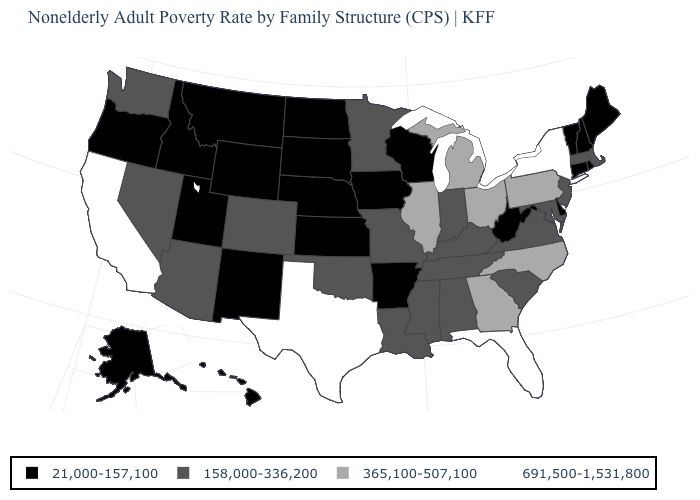Which states hav the highest value in the West?
Quick response, please. California. What is the value of Missouri?
Concise answer only. 158,000-336,200. Which states hav the highest value in the West?
Be succinct. California. What is the value of North Carolina?
Quick response, please. 365,100-507,100. Does North Dakota have the lowest value in the MidWest?
Write a very short answer. Yes. What is the highest value in states that border Vermont?
Quick response, please. 691,500-1,531,800. Name the states that have a value in the range 365,100-507,100?
Give a very brief answer. Georgia, Illinois, Michigan, North Carolina, Ohio, Pennsylvania. Name the states that have a value in the range 365,100-507,100?
Quick response, please. Georgia, Illinois, Michigan, North Carolina, Ohio, Pennsylvania. What is the value of Alabama?
Quick response, please. 158,000-336,200. Among the states that border Maryland , does Delaware have the lowest value?
Write a very short answer. Yes. What is the value of Colorado?
Give a very brief answer. 158,000-336,200. What is the lowest value in the MidWest?
Keep it brief. 21,000-157,100. What is the highest value in states that border New Jersey?
Short answer required. 691,500-1,531,800. Does Pennsylvania have the lowest value in the Northeast?
Concise answer only. No. What is the highest value in states that border New Mexico?
Give a very brief answer. 691,500-1,531,800. 